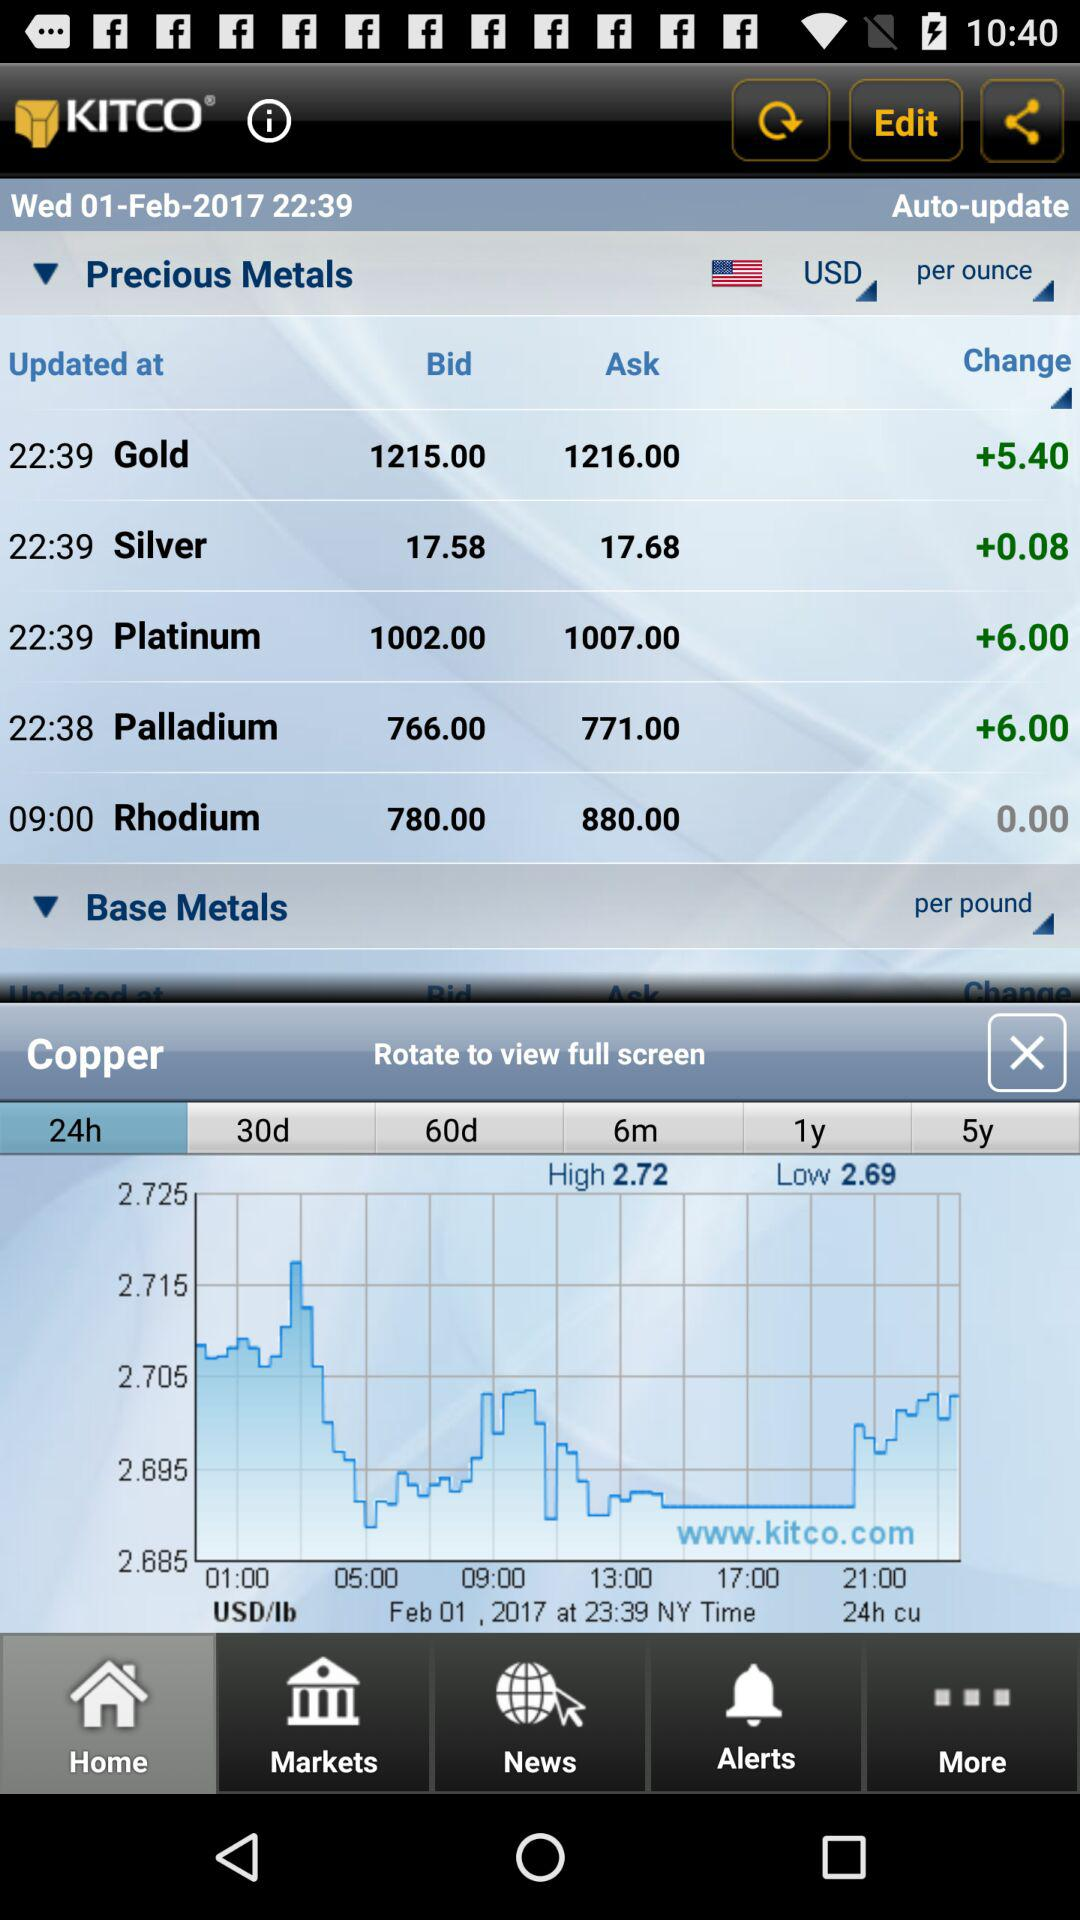What is the change in gold? The change in gold is +5.40. 